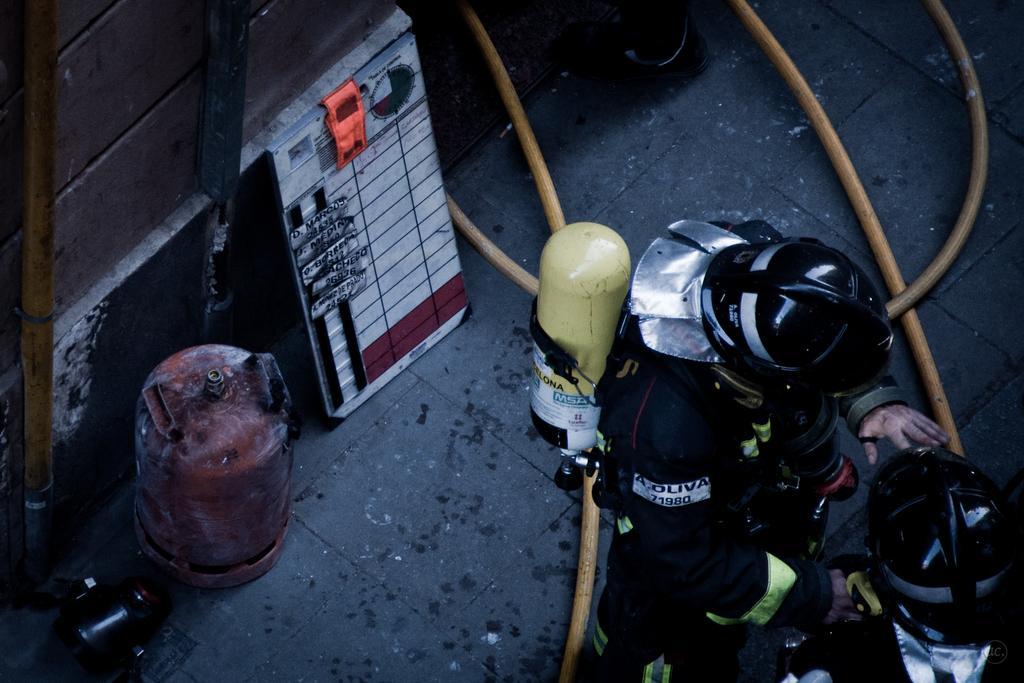Could you give a brief overview of what you see in this image? Here in this picture we can see two persons standing on the road and both of them are wearing safety suits and helmets on them and the person in the middle is carrying a cylinder on his back and behind him we can see another cylinder and a board present and on the road we can see pores all over there. 